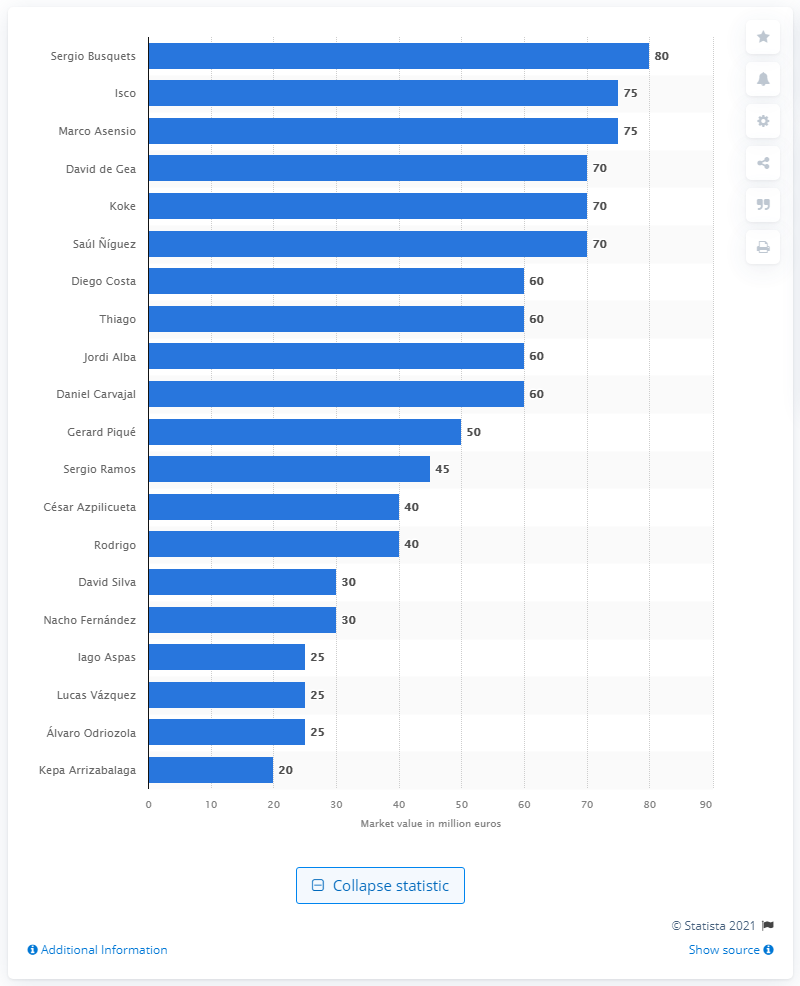Give some essential details in this illustration. The most valuable player at the 2018 FIFA World Cup was Sergio Busquets. Sergio Busquets' market value was 80.. 